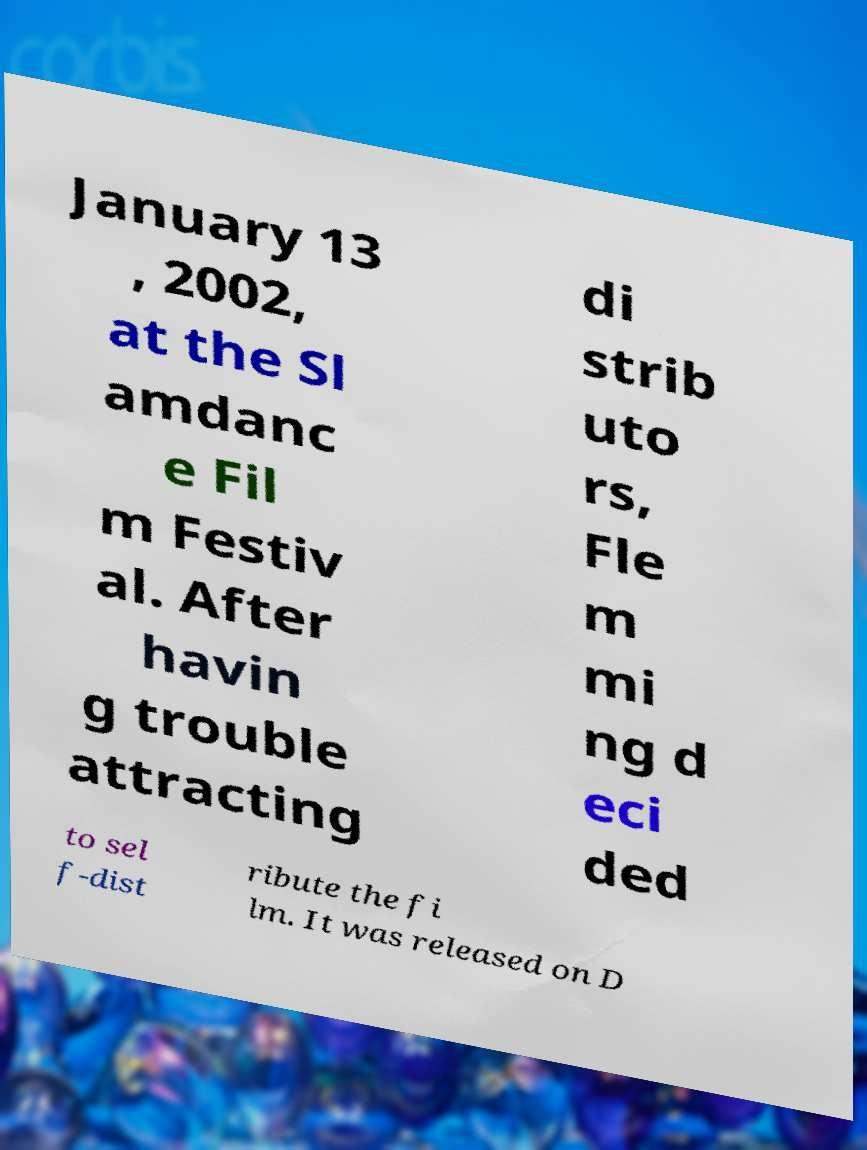Could you extract and type out the text from this image? January 13 , 2002, at the Sl amdanc e Fil m Festiv al. After havin g trouble attracting di strib uto rs, Fle m mi ng d eci ded to sel f-dist ribute the fi lm. It was released on D 